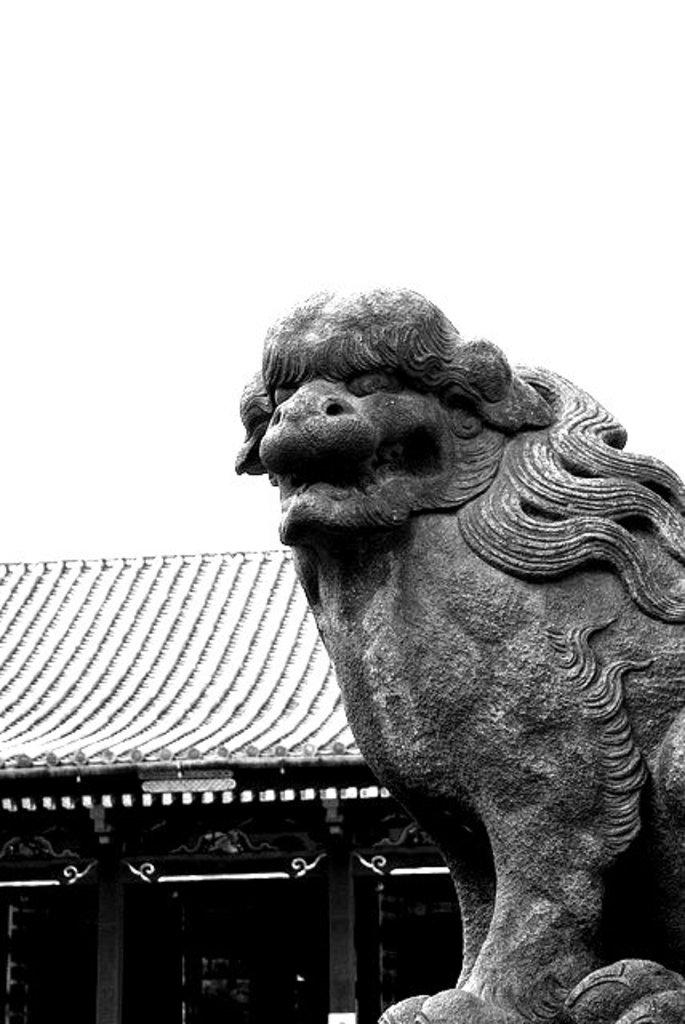What is located on the right side of the image? There is a statue on the right side of the image. What can be seen in the background of the image? There is a building in the background of the image. What architectural feature is present on the building? The building has pillars. What is the color scheme of the image? The image is black and white. Can you tell me how many brushes are being used to control the statue in the image? There are no brushes or control mechanisms present in the image; it features a statue and a building with pillars. What type of knee injury can be seen on the statue in the image? There is no knee injury or any other type of injury depicted on the statue in the image. 